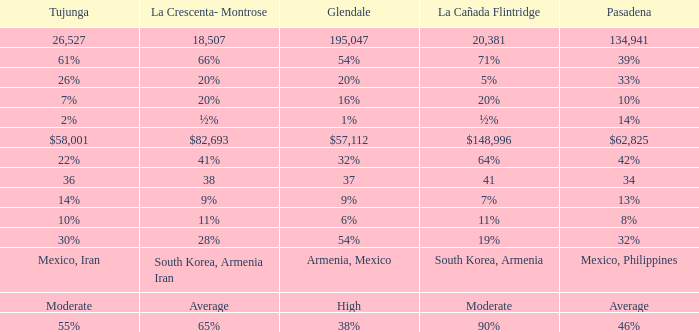What is the percentage of Glendale when Pasadena is 14%? 1%. 